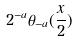<formula> <loc_0><loc_0><loc_500><loc_500>2 ^ { - a } \theta _ { - a } ( \frac { x } { 2 } )</formula> 